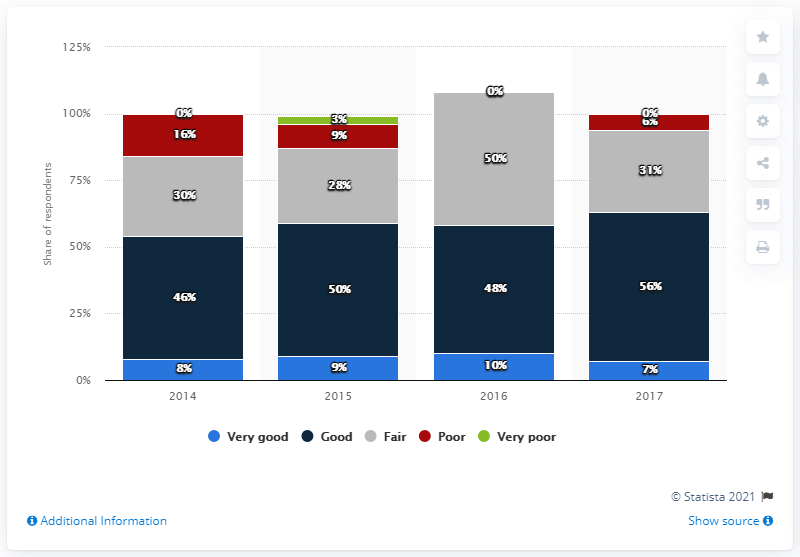Indicate a few pertinent items in this graphic. In the year 2016, political changes had a significant impact on the appetite for long-term specialty commercial property investments on the European market. 